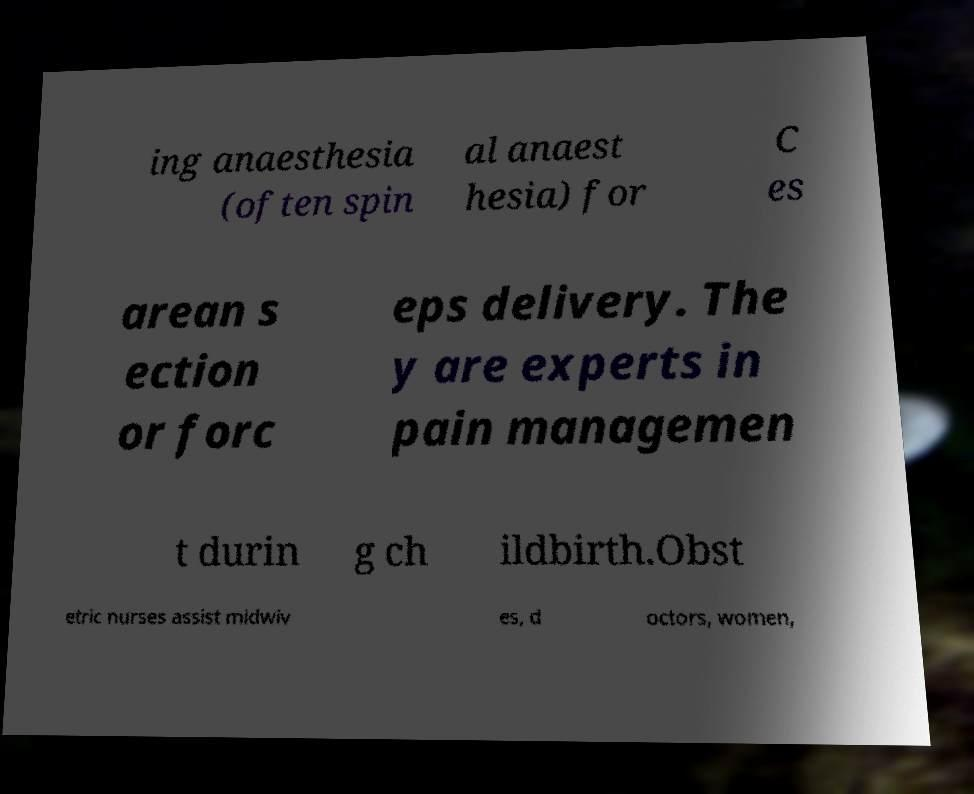I need the written content from this picture converted into text. Can you do that? ing anaesthesia (often spin al anaest hesia) for C es arean s ection or forc eps delivery. The y are experts in pain managemen t durin g ch ildbirth.Obst etric nurses assist midwiv es, d octors, women, 